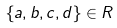Convert formula to latex. <formula><loc_0><loc_0><loc_500><loc_500>\{ a , b , c , d \} \in R</formula> 